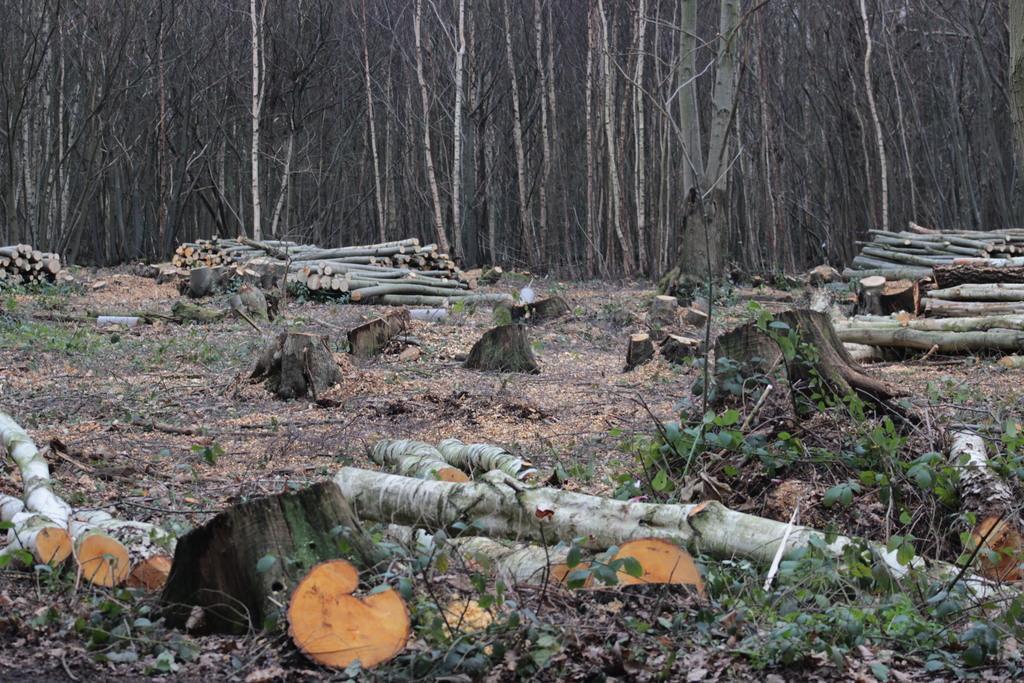How would you summarize this image in a sentence or two? In the center of the image we can see a wood logs are present. In the background of the image a trees are there. At the bottom of the image some plants and ground are present. 